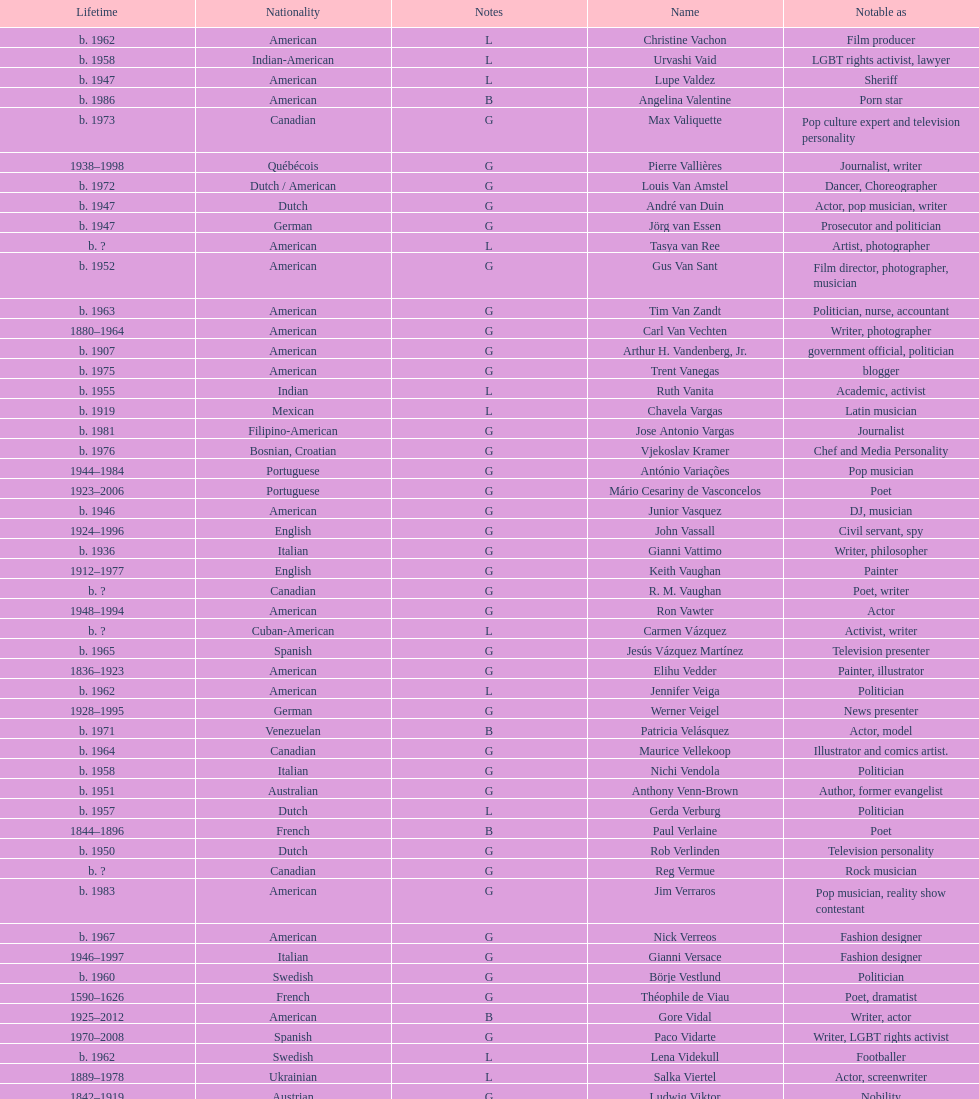How old was pierre vallieres before he died? 60. 